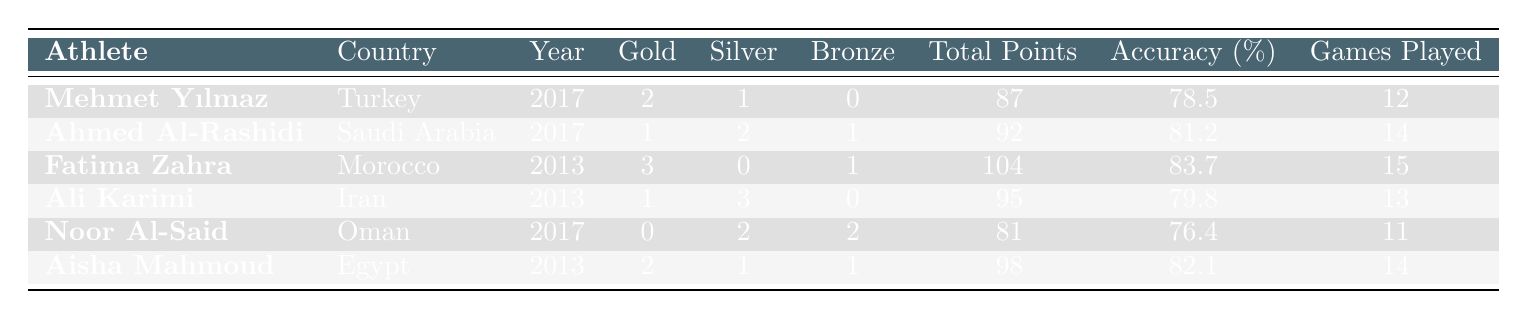What is the maximum number of gold medals won by an athlete? The maximum number of gold medals can be found by inspecting the "Gold Medals" column. The highest value is 3, which belongs to Fatima Zahra from Morocco.
Answer: 3 Which athlete scored the highest total points? By looking at the "Total Points Scored" column, I can compare all the values. Fatima Zahra scored 104 points, which is the highest among all listed athletes.
Answer: 104 How many medals did Aisha Mahmoud win in total? To find the total number of medals won by Aisha Mahmoud, I will add the number of gold, silver, and bronze medals: 2 (Gold) + 1 (Silver) + 1 (Bronze) = 4 medals.
Answer: 4 Does any athlete have an accuracy percentage higher than 80%? Checking the "Accuracy (%)" column, I see that Fatima Zahra (83.7%) and Ahmed Al-Rashidi (81.2%) both have accuracy percentages above 80%. Therefore, the statement is true.
Answer: Yes What is the average accuracy of all athletes in the table? To calculate the average, I will first sum the accuracy percentages: 78.5 + 81.2 + 83.7 + 79.8 + 76.4 + 82.1 = 481.7. Then I divide by the number of athletes (6): 481.7 / 6 = 80.2833, which rounds to approximately 80.3.
Answer: 80.3 Who played the least number of games? By checking the "Games Played" column, I see that Noor Al-Said played the least number of games at 11.
Answer: 11 How many total medals did Turkey win across all its athletes in the table? For Turkey, only Mehmet Yılmaz is listed. He won 2 Gold and 1 Silver. Therefore, the total is 2 + 1 = 3 medals.
Answer: 3 Which athlete participated in the most games? Observing the "Games Played" column, I see that Fatima Zahra played the most games, totaling 15.
Answer: 15 